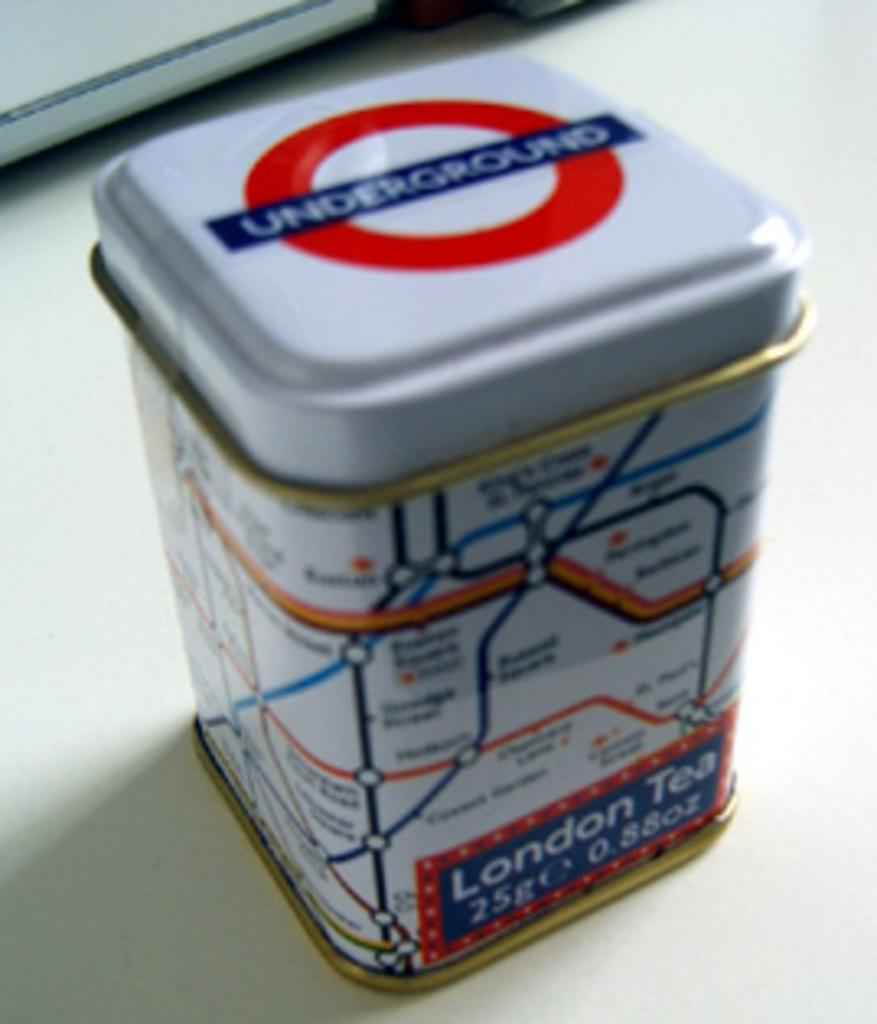Provide a one-sentence caption for the provided image. London Tea sometimes comes in a tin with UNDERGROUND written on the lid. 